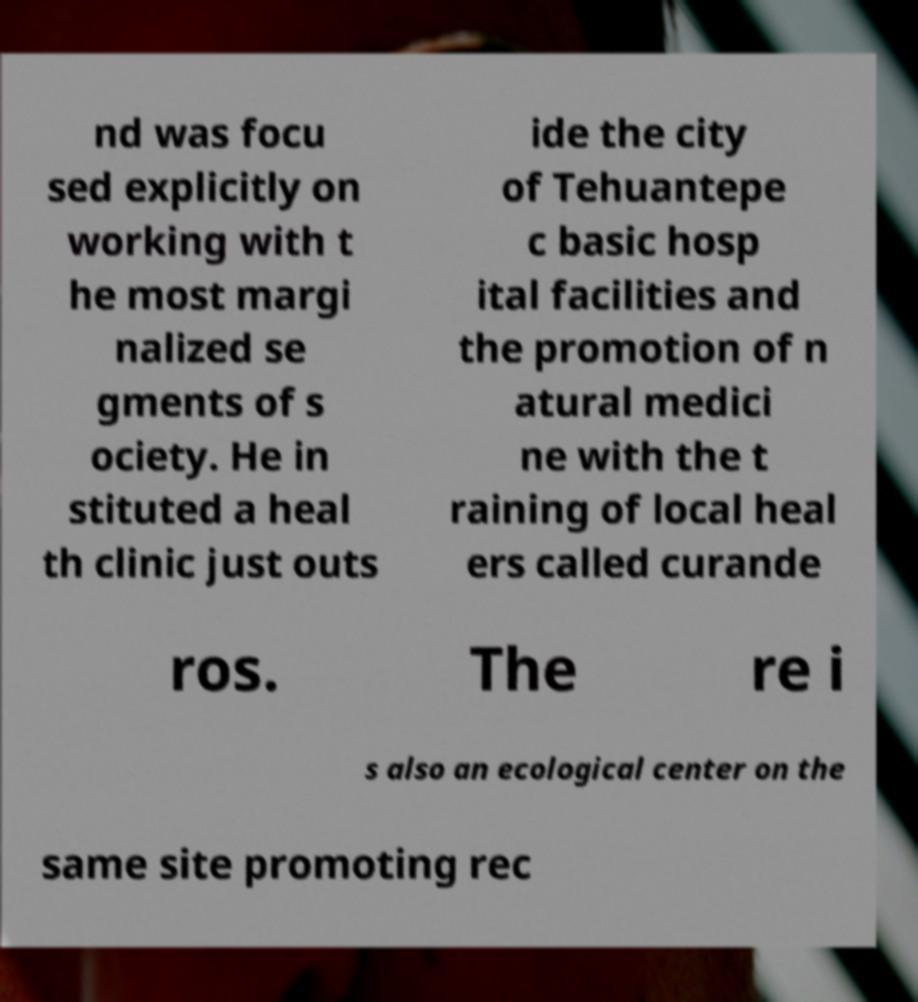Can you accurately transcribe the text from the provided image for me? nd was focu sed explicitly on working with t he most margi nalized se gments of s ociety. He in stituted a heal th clinic just outs ide the city of Tehuantepe c basic hosp ital facilities and the promotion of n atural medici ne with the t raining of local heal ers called curande ros. The re i s also an ecological center on the same site promoting rec 